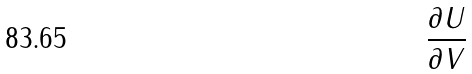<formula> <loc_0><loc_0><loc_500><loc_500>\frac { \partial U } { \partial V }</formula> 